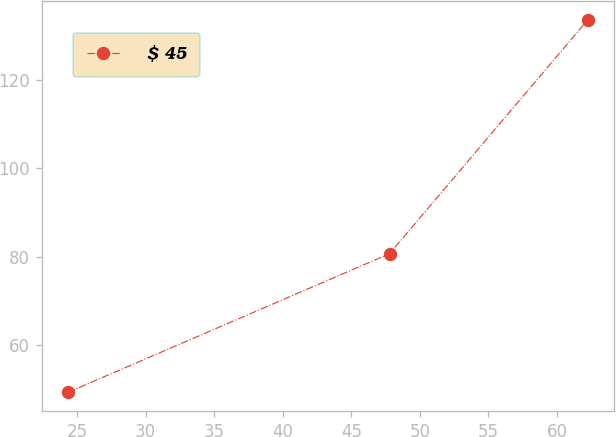Convert chart to OTSL. <chart><loc_0><loc_0><loc_500><loc_500><line_chart><ecel><fcel>$ 45<nl><fcel>24.33<fcel>49.34<nl><fcel>47.79<fcel>80.72<nl><fcel>62.24<fcel>133.57<nl></chart> 